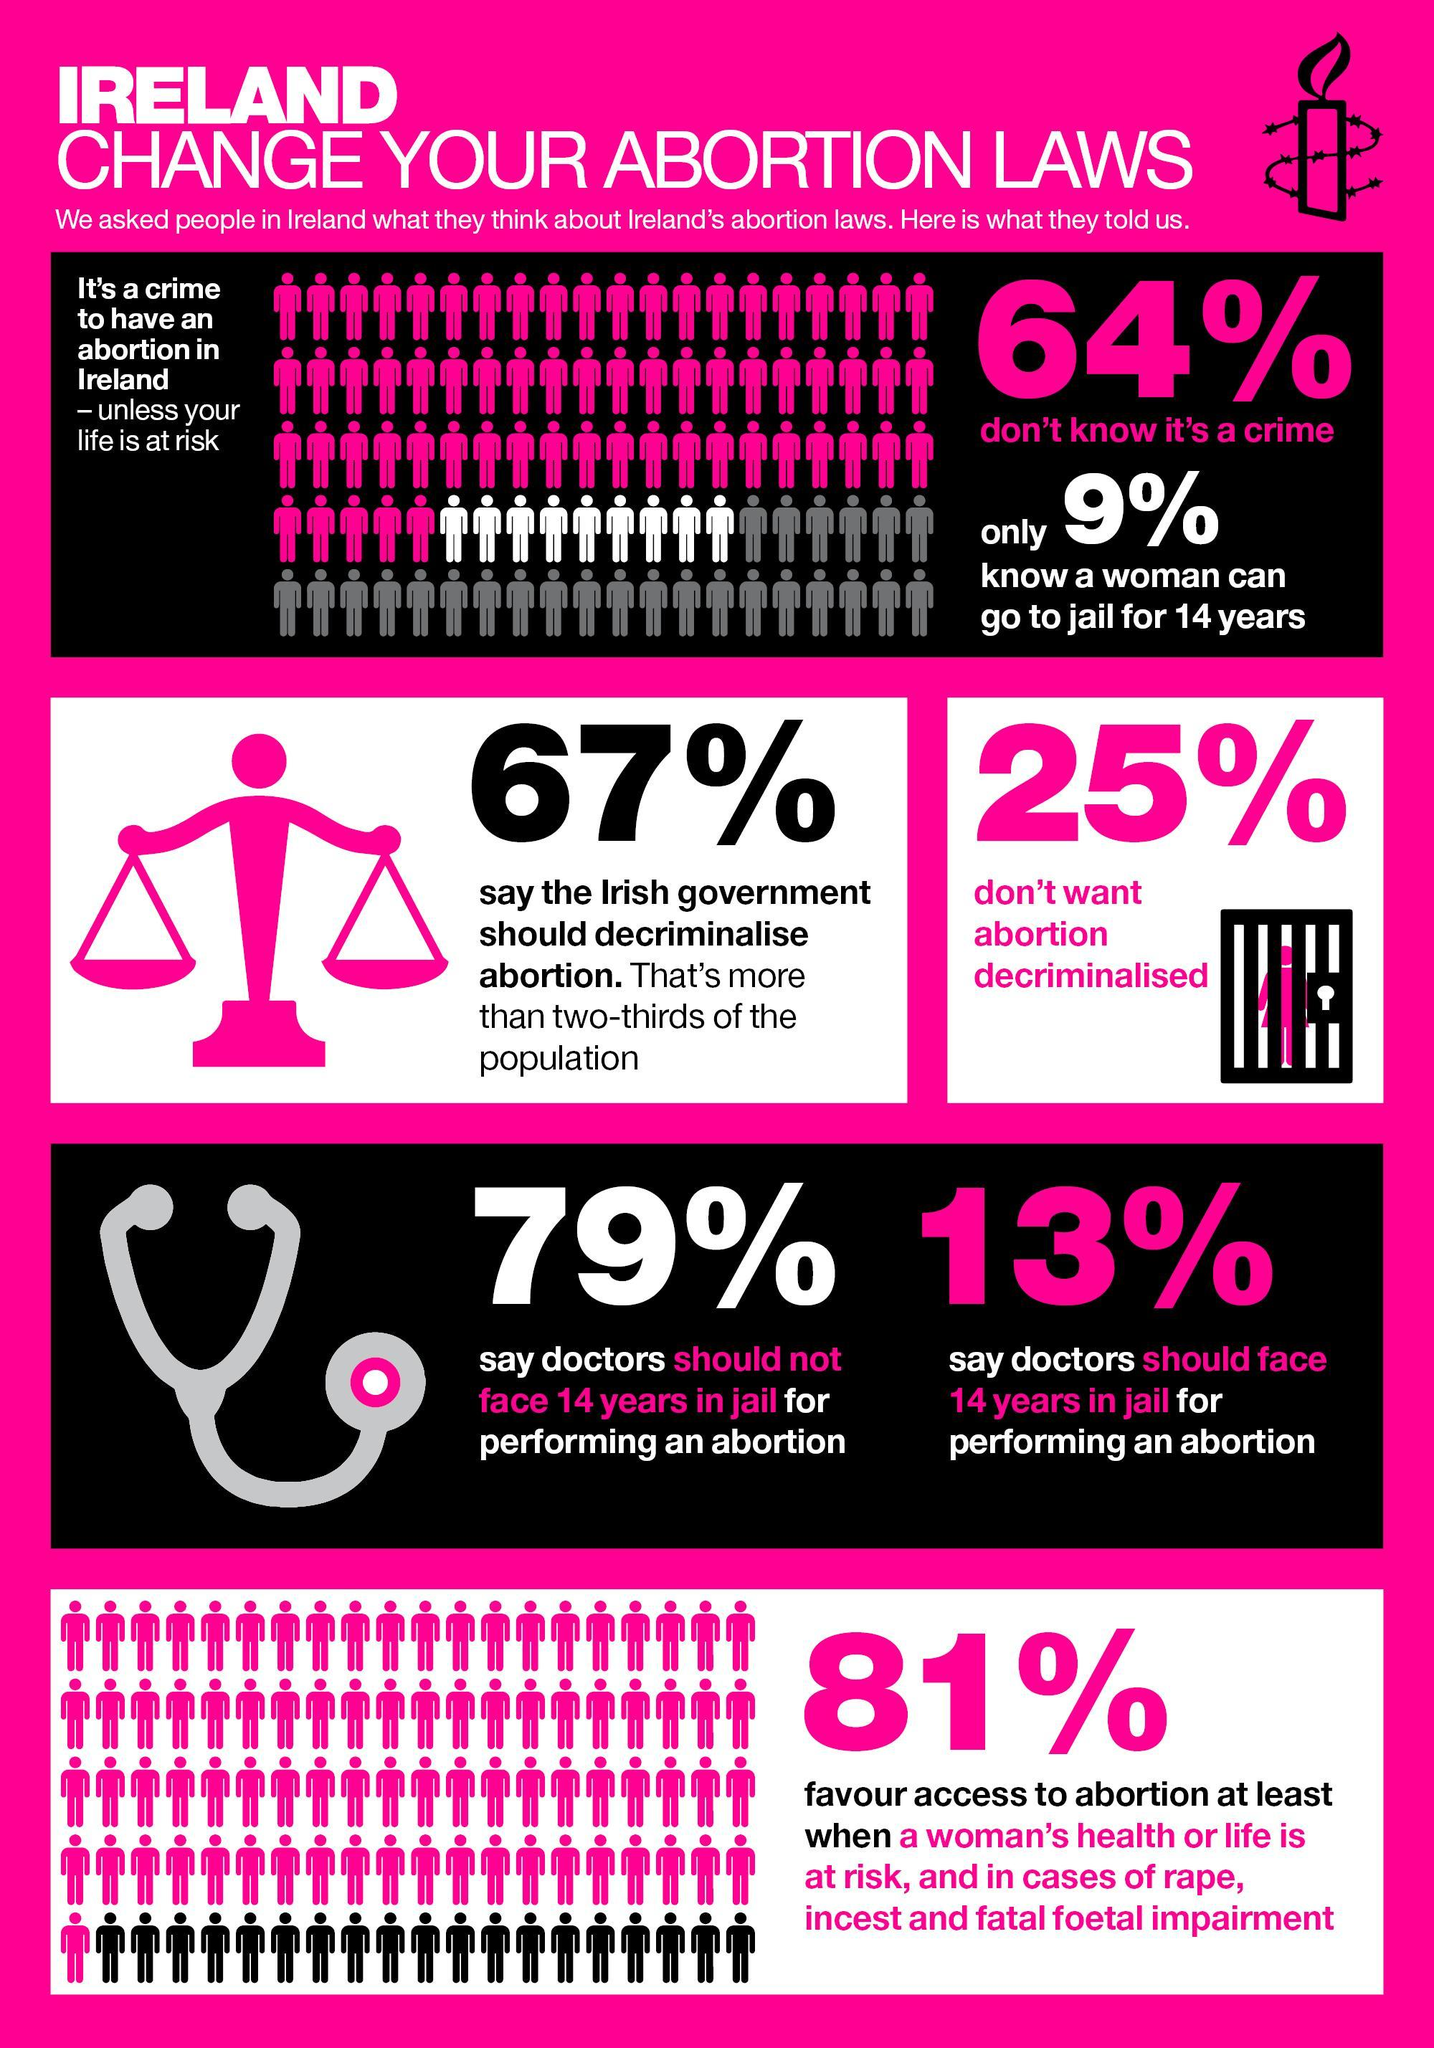How many of the people do not want government to decriminalise abortion?
Answer the question with a short phrase. 25% How many people are of the opinion that doctors should face jail term for performing abortion? 13% How many people say that doctors should not be punished for performing abortion? 79% What is the punishment for a female for having an abortion? go to jail for 14 years What percent of people in Ireland are not aware that abortion is a crime? 64% What is the opinion of two-thirds of the Irish population about abortion? government should decriminalise abortion How many of the people know that abortion carries a 14-year jail sentence? 9% When is the only exceptional situation in which abortion is allowed as per Ireland's laws? life is at risk Besides life or health risk, which other cases should be allowed for abortion as per 81% of people? cases of rape, incest and fatal foetal impairment How many of the people say that abortion should be decriminalised? 67% 